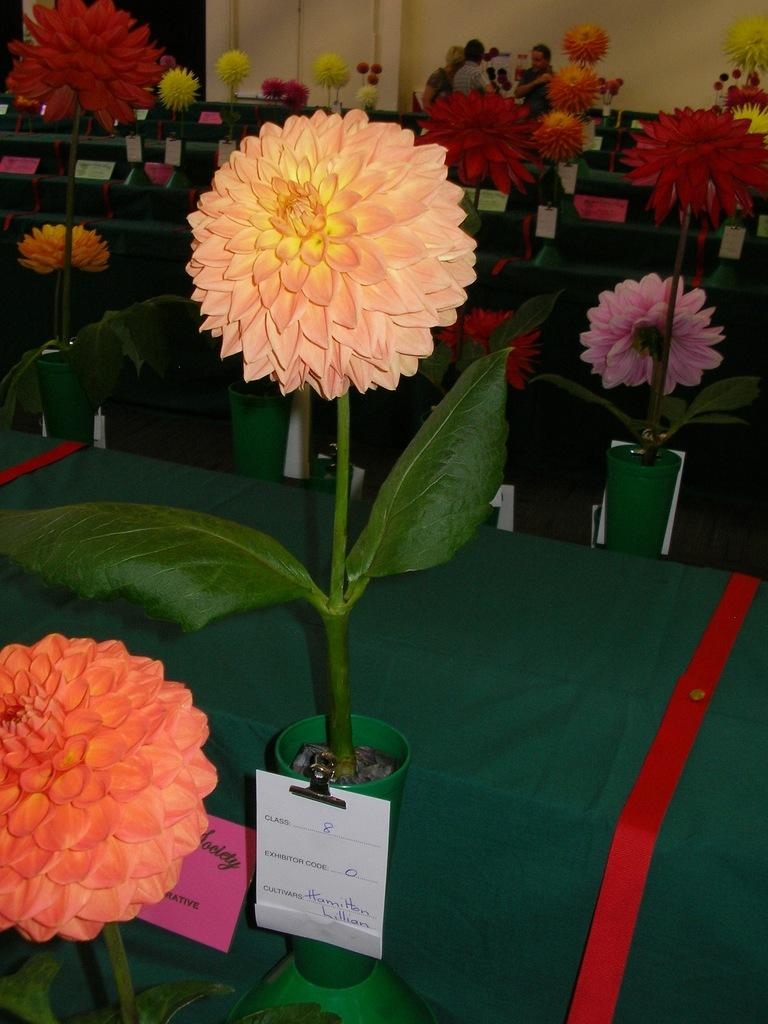What type of living organisms can be seen in the image? There are flowers in the image. What is the color of the surface on which the flowers are placed? The flowers are on a green surface. What can be seen in the background of the image? There are people and a wall in the background of the image. What type of bird is perched on the scarecrow in the image? There is no scarecrow or bird present in the image; it features flowers on a green surface with people and a wall in the background. 